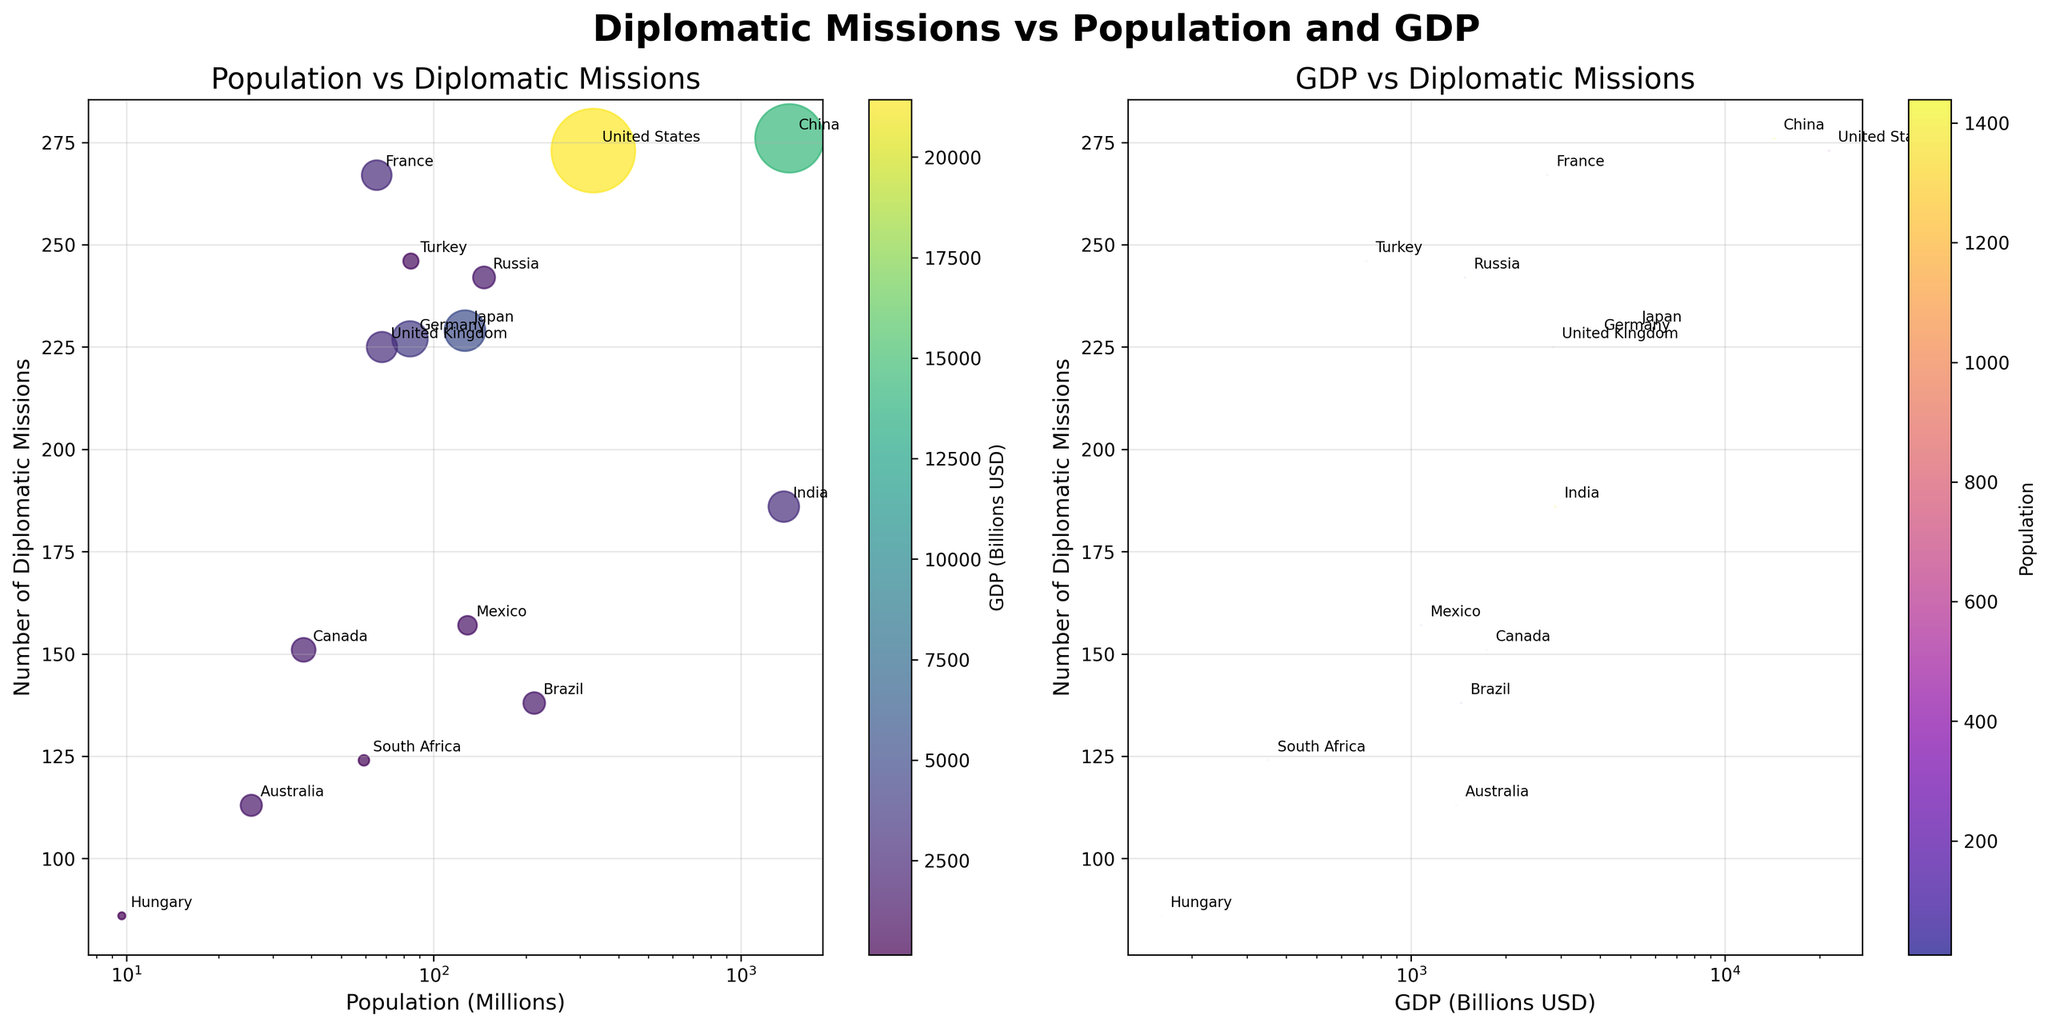What is the title of the figure? The title is displayed at the top center of the figure. It reads "Diplomatic Missions vs Population and GDP."
Answer: Diplomatic Missions vs. Population and GDP What axis represents the number of diplomatic missions in both plots? In both subplots, the y-axis represents the number of diplomatic missions.
Answer: y-axis Which country's bubble is the largest in the Population vs Diplomatic Missions plot? The largest bubble in the Population vs Diplomatic Missions plot corresponds to China, which has the highest population.
Answer: China How does the United States compare to China in terms of the number of diplomatic missions? From the figure, the United States has slightly fewer diplomatic missions compared to China. This is evidenced by the bubbles for the U.S. and China in the Population vs Diplomatic Missions plot, where China's bubble is slightly higher on the y-axis.
Answer: United States has slightly fewer Which country has the highest GDP in the second subplot (GDP vs Diplomatic Missions)? The highest GDP in the GDP vs Diplomatic Missions plot is represented by the United States. The bubble for the United States is the furthest to the right on the x-axis.
Answer: United States What does the color of the bubbles represent in the Population vs Diplomatic Missions plot? In the Population vs Diplomatic Missions plot, the color of the bubbles represents GDP, as indicated by the color bar on the right-hand side of the plot.
Answer: GDP Which country has more diplomatic missions, Russia or Japan? In both plots (Population vs Diplomatic Missions and GDP vs Diplomatic Missions), Russia has more diplomatic missions than Japan, as its bubble is positioned higher on the y-axis.
Answer: Russia How is the number of diplomatic missions related to GDP for countries with a GDP greater than 3000 billion USD in the second plot? For countries with a GDP greater than 3000 billion USD (United States, China, Germany, and Japan), there is a positive relationship between GDP and the number of diplomatic missions. The bubbles for these countries are located in the upper-right portion of the GDP vs Diplomatic Missions plot.
Answer: Positive relationship Why is Brazil's bubble smaller in the GDP vs Diplomatic Missions plot compared to the Population vs Diplomatic Missions plot? In the GDP vs Diplomatic Missions plot, the size of the bubbles is determined by the population. Since Brazil has a high population but relatively lower GDP, its bubble appears smaller compared to other countries with higher GDP but smaller populations.
Answer: Higher population, lower GDP What is the approximate value of Hungary's GDP? Hungary's bubble in the GDP vs Diplomatic Missions plot is located approximately at the 160 billion USD mark on the x-axis, as indicated by its position.
Answer: 160 billion USD 